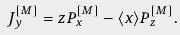<formula> <loc_0><loc_0><loc_500><loc_500>J ^ { [ M ] } _ { y } = z P ^ { [ M ] } _ { x } - \langle x \rangle P ^ { [ M ] } _ { z } .</formula> 